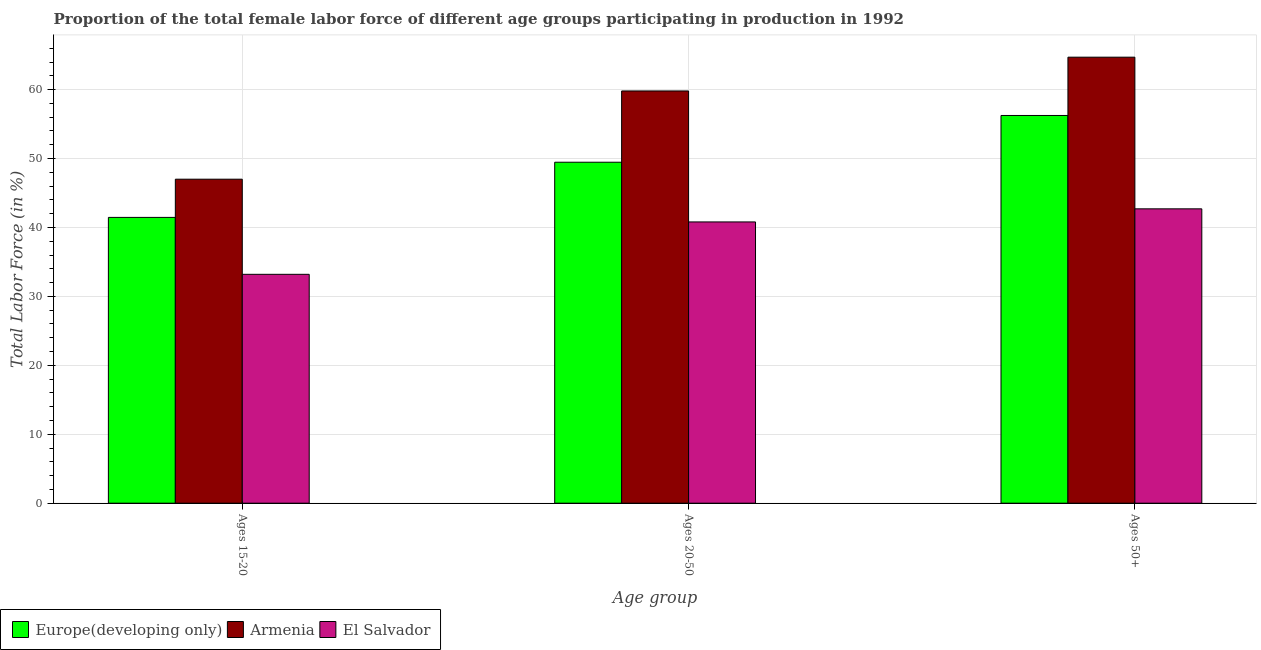Are the number of bars per tick equal to the number of legend labels?
Your answer should be very brief. Yes. Are the number of bars on each tick of the X-axis equal?
Ensure brevity in your answer.  Yes. How many bars are there on the 2nd tick from the left?
Offer a terse response. 3. What is the label of the 3rd group of bars from the left?
Provide a short and direct response. Ages 50+. What is the percentage of female labor force within the age group 15-20 in El Salvador?
Your answer should be compact. 33.2. Across all countries, what is the maximum percentage of female labor force within the age group 15-20?
Offer a terse response. 47. Across all countries, what is the minimum percentage of female labor force above age 50?
Ensure brevity in your answer.  42.7. In which country was the percentage of female labor force above age 50 maximum?
Your answer should be very brief. Armenia. In which country was the percentage of female labor force within the age group 20-50 minimum?
Give a very brief answer. El Salvador. What is the total percentage of female labor force within the age group 15-20 in the graph?
Provide a succinct answer. 121.66. What is the difference between the percentage of female labor force within the age group 15-20 in Europe(developing only) and that in El Salvador?
Your answer should be compact. 8.26. What is the difference between the percentage of female labor force above age 50 in Europe(developing only) and the percentage of female labor force within the age group 20-50 in El Salvador?
Keep it short and to the point. 15.44. What is the average percentage of female labor force above age 50 per country?
Keep it short and to the point. 54.55. What is the difference between the percentage of female labor force within the age group 15-20 and percentage of female labor force above age 50 in El Salvador?
Offer a very short reply. -9.5. What is the ratio of the percentage of female labor force within the age group 20-50 in El Salvador to that in Armenia?
Your response must be concise. 0.68. Is the difference between the percentage of female labor force within the age group 15-20 in Armenia and Europe(developing only) greater than the difference between the percentage of female labor force above age 50 in Armenia and Europe(developing only)?
Provide a succinct answer. No. What is the difference between the highest and the second highest percentage of female labor force within the age group 20-50?
Ensure brevity in your answer.  10.34. Is the sum of the percentage of female labor force within the age group 20-50 in Europe(developing only) and Armenia greater than the maximum percentage of female labor force above age 50 across all countries?
Offer a terse response. Yes. What does the 2nd bar from the left in Ages 50+ represents?
Offer a terse response. Armenia. What does the 1st bar from the right in Ages 20-50 represents?
Ensure brevity in your answer.  El Salvador. Is it the case that in every country, the sum of the percentage of female labor force within the age group 15-20 and percentage of female labor force within the age group 20-50 is greater than the percentage of female labor force above age 50?
Keep it short and to the point. Yes. How many bars are there?
Ensure brevity in your answer.  9. How many countries are there in the graph?
Provide a short and direct response. 3. What is the difference between two consecutive major ticks on the Y-axis?
Ensure brevity in your answer.  10. Are the values on the major ticks of Y-axis written in scientific E-notation?
Give a very brief answer. No. Does the graph contain any zero values?
Provide a succinct answer. No. How are the legend labels stacked?
Your answer should be compact. Horizontal. What is the title of the graph?
Your response must be concise. Proportion of the total female labor force of different age groups participating in production in 1992. What is the label or title of the X-axis?
Provide a succinct answer. Age group. What is the Total Labor Force (in %) in Europe(developing only) in Ages 15-20?
Provide a succinct answer. 41.46. What is the Total Labor Force (in %) of El Salvador in Ages 15-20?
Your answer should be compact. 33.2. What is the Total Labor Force (in %) of Europe(developing only) in Ages 20-50?
Keep it short and to the point. 49.46. What is the Total Labor Force (in %) in Armenia in Ages 20-50?
Your answer should be compact. 59.8. What is the Total Labor Force (in %) in El Salvador in Ages 20-50?
Provide a short and direct response. 40.8. What is the Total Labor Force (in %) in Europe(developing only) in Ages 50+?
Provide a short and direct response. 56.24. What is the Total Labor Force (in %) in Armenia in Ages 50+?
Provide a succinct answer. 64.7. What is the Total Labor Force (in %) in El Salvador in Ages 50+?
Make the answer very short. 42.7. Across all Age group, what is the maximum Total Labor Force (in %) in Europe(developing only)?
Keep it short and to the point. 56.24. Across all Age group, what is the maximum Total Labor Force (in %) of Armenia?
Your answer should be very brief. 64.7. Across all Age group, what is the maximum Total Labor Force (in %) of El Salvador?
Your answer should be very brief. 42.7. Across all Age group, what is the minimum Total Labor Force (in %) of Europe(developing only)?
Your answer should be compact. 41.46. Across all Age group, what is the minimum Total Labor Force (in %) of El Salvador?
Your answer should be compact. 33.2. What is the total Total Labor Force (in %) of Europe(developing only) in the graph?
Give a very brief answer. 147.16. What is the total Total Labor Force (in %) of Armenia in the graph?
Keep it short and to the point. 171.5. What is the total Total Labor Force (in %) of El Salvador in the graph?
Provide a succinct answer. 116.7. What is the difference between the Total Labor Force (in %) of Europe(developing only) in Ages 15-20 and that in Ages 20-50?
Your answer should be compact. -8. What is the difference between the Total Labor Force (in %) of Europe(developing only) in Ages 15-20 and that in Ages 50+?
Offer a very short reply. -14.79. What is the difference between the Total Labor Force (in %) of Armenia in Ages 15-20 and that in Ages 50+?
Your response must be concise. -17.7. What is the difference between the Total Labor Force (in %) of Europe(developing only) in Ages 20-50 and that in Ages 50+?
Your answer should be very brief. -6.78. What is the difference between the Total Labor Force (in %) of Europe(developing only) in Ages 15-20 and the Total Labor Force (in %) of Armenia in Ages 20-50?
Keep it short and to the point. -18.34. What is the difference between the Total Labor Force (in %) of Europe(developing only) in Ages 15-20 and the Total Labor Force (in %) of El Salvador in Ages 20-50?
Your answer should be compact. 0.66. What is the difference between the Total Labor Force (in %) of Europe(developing only) in Ages 15-20 and the Total Labor Force (in %) of Armenia in Ages 50+?
Provide a short and direct response. -23.24. What is the difference between the Total Labor Force (in %) of Europe(developing only) in Ages 15-20 and the Total Labor Force (in %) of El Salvador in Ages 50+?
Offer a terse response. -1.24. What is the difference between the Total Labor Force (in %) of Armenia in Ages 15-20 and the Total Labor Force (in %) of El Salvador in Ages 50+?
Make the answer very short. 4.3. What is the difference between the Total Labor Force (in %) in Europe(developing only) in Ages 20-50 and the Total Labor Force (in %) in Armenia in Ages 50+?
Provide a short and direct response. -15.24. What is the difference between the Total Labor Force (in %) of Europe(developing only) in Ages 20-50 and the Total Labor Force (in %) of El Salvador in Ages 50+?
Keep it short and to the point. 6.76. What is the average Total Labor Force (in %) of Europe(developing only) per Age group?
Provide a short and direct response. 49.05. What is the average Total Labor Force (in %) in Armenia per Age group?
Offer a very short reply. 57.17. What is the average Total Labor Force (in %) of El Salvador per Age group?
Your answer should be compact. 38.9. What is the difference between the Total Labor Force (in %) in Europe(developing only) and Total Labor Force (in %) in Armenia in Ages 15-20?
Provide a short and direct response. -5.54. What is the difference between the Total Labor Force (in %) in Europe(developing only) and Total Labor Force (in %) in El Salvador in Ages 15-20?
Your answer should be compact. 8.26. What is the difference between the Total Labor Force (in %) of Armenia and Total Labor Force (in %) of El Salvador in Ages 15-20?
Give a very brief answer. 13.8. What is the difference between the Total Labor Force (in %) of Europe(developing only) and Total Labor Force (in %) of Armenia in Ages 20-50?
Keep it short and to the point. -10.34. What is the difference between the Total Labor Force (in %) of Europe(developing only) and Total Labor Force (in %) of El Salvador in Ages 20-50?
Ensure brevity in your answer.  8.66. What is the difference between the Total Labor Force (in %) of Armenia and Total Labor Force (in %) of El Salvador in Ages 20-50?
Ensure brevity in your answer.  19. What is the difference between the Total Labor Force (in %) of Europe(developing only) and Total Labor Force (in %) of Armenia in Ages 50+?
Your answer should be compact. -8.46. What is the difference between the Total Labor Force (in %) in Europe(developing only) and Total Labor Force (in %) in El Salvador in Ages 50+?
Provide a succinct answer. 13.54. What is the ratio of the Total Labor Force (in %) in Europe(developing only) in Ages 15-20 to that in Ages 20-50?
Keep it short and to the point. 0.84. What is the ratio of the Total Labor Force (in %) in Armenia in Ages 15-20 to that in Ages 20-50?
Offer a terse response. 0.79. What is the ratio of the Total Labor Force (in %) in El Salvador in Ages 15-20 to that in Ages 20-50?
Your response must be concise. 0.81. What is the ratio of the Total Labor Force (in %) in Europe(developing only) in Ages 15-20 to that in Ages 50+?
Your response must be concise. 0.74. What is the ratio of the Total Labor Force (in %) in Armenia in Ages 15-20 to that in Ages 50+?
Provide a short and direct response. 0.73. What is the ratio of the Total Labor Force (in %) of El Salvador in Ages 15-20 to that in Ages 50+?
Offer a very short reply. 0.78. What is the ratio of the Total Labor Force (in %) of Europe(developing only) in Ages 20-50 to that in Ages 50+?
Your response must be concise. 0.88. What is the ratio of the Total Labor Force (in %) of Armenia in Ages 20-50 to that in Ages 50+?
Provide a succinct answer. 0.92. What is the ratio of the Total Labor Force (in %) of El Salvador in Ages 20-50 to that in Ages 50+?
Provide a succinct answer. 0.96. What is the difference between the highest and the second highest Total Labor Force (in %) in Europe(developing only)?
Your response must be concise. 6.78. What is the difference between the highest and the second highest Total Labor Force (in %) of El Salvador?
Your response must be concise. 1.9. What is the difference between the highest and the lowest Total Labor Force (in %) of Europe(developing only)?
Provide a succinct answer. 14.79. What is the difference between the highest and the lowest Total Labor Force (in %) in El Salvador?
Give a very brief answer. 9.5. 